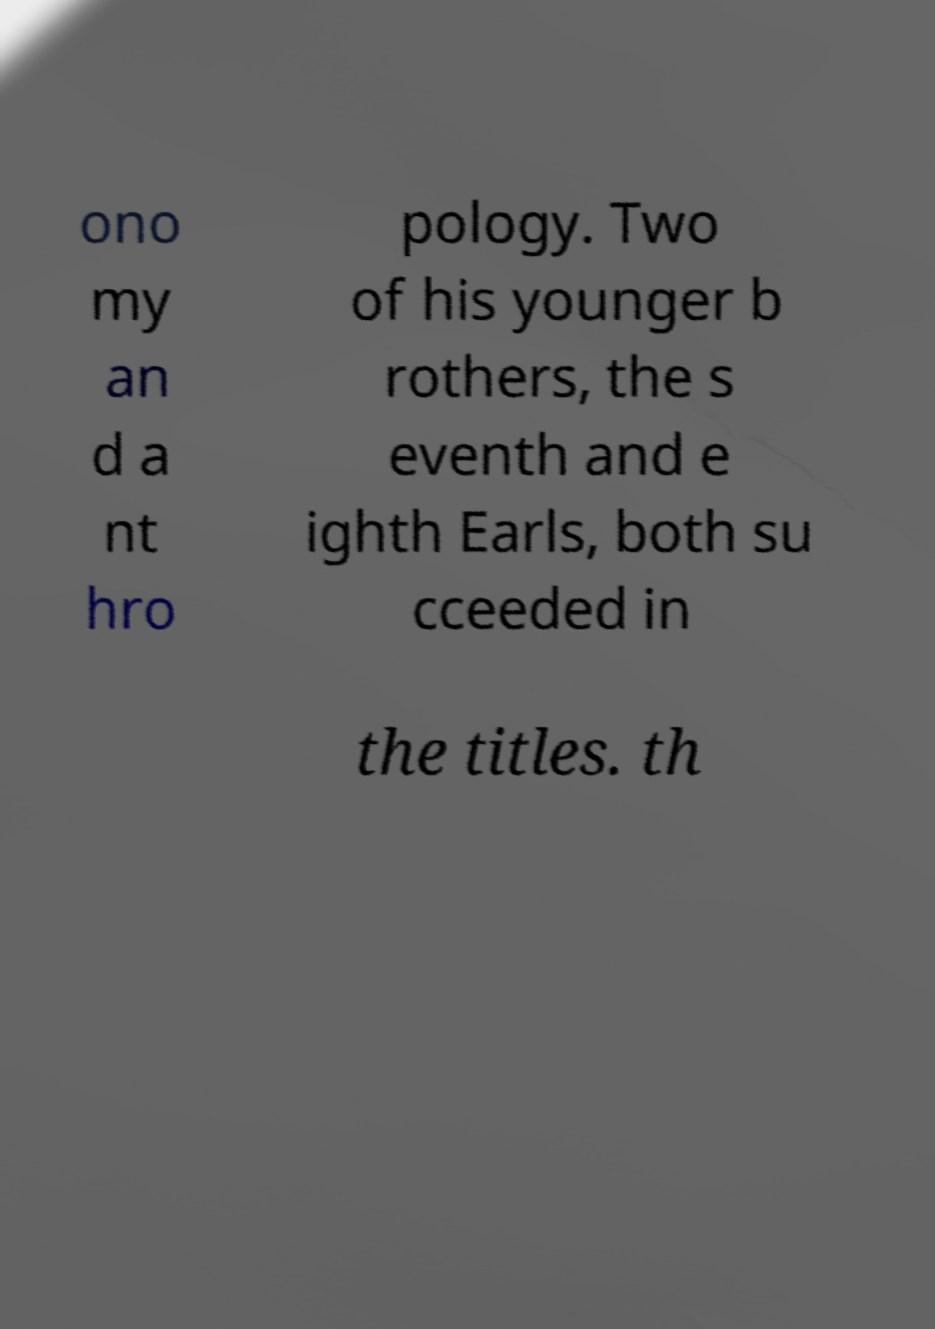I need the written content from this picture converted into text. Can you do that? ono my an d a nt hro pology. Two of his younger b rothers, the s eventh and e ighth Earls, both su cceeded in the titles. th 